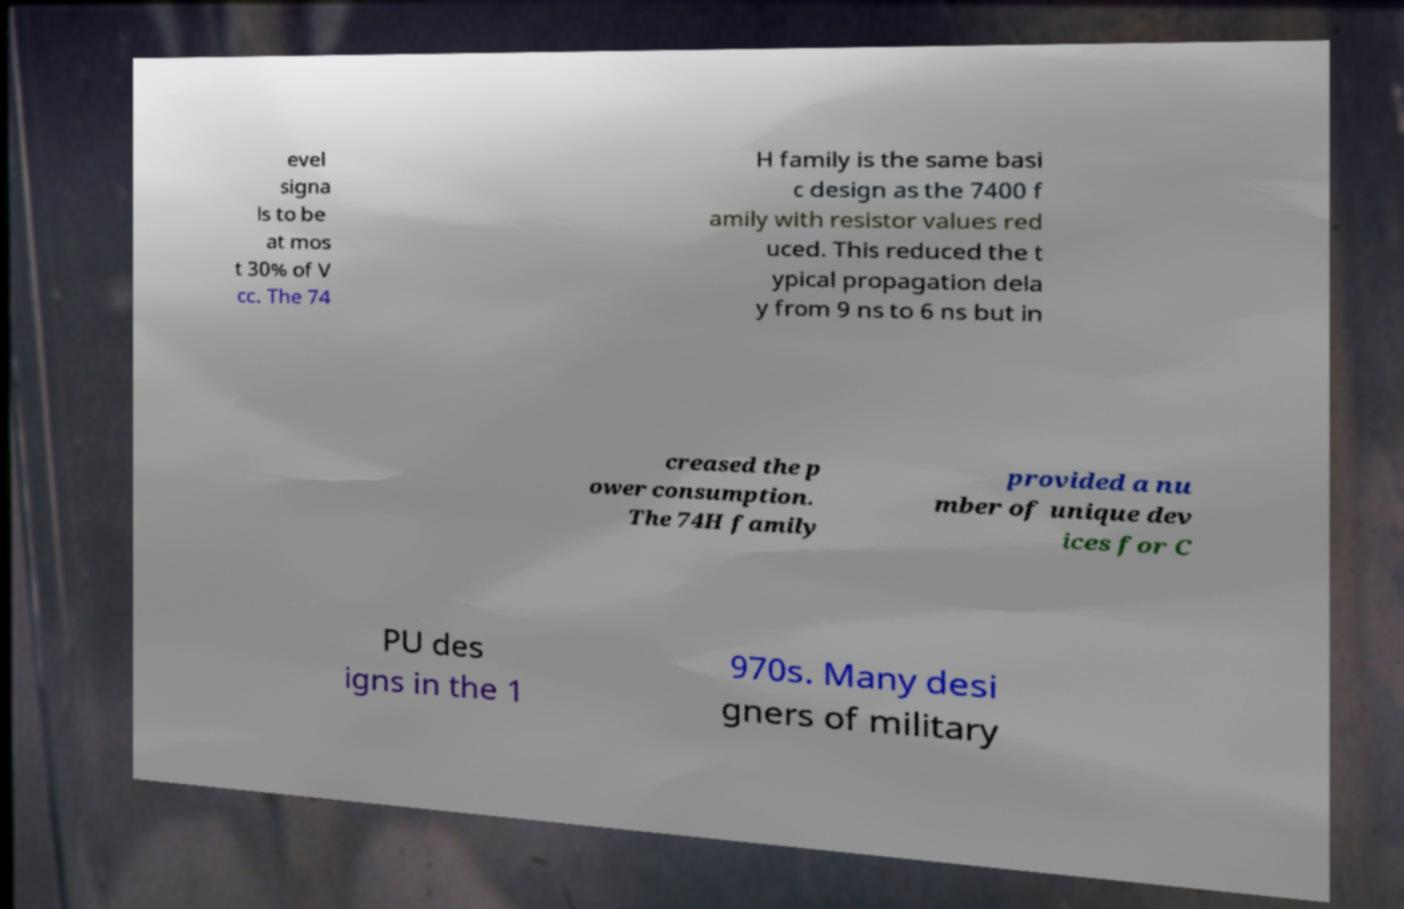Please read and relay the text visible in this image. What does it say? evel signa ls to be at mos t 30% of V cc. The 74 H family is the same basi c design as the 7400 f amily with resistor values red uced. This reduced the t ypical propagation dela y from 9 ns to 6 ns but in creased the p ower consumption. The 74H family provided a nu mber of unique dev ices for C PU des igns in the 1 970s. Many desi gners of military 